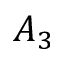<formula> <loc_0><loc_0><loc_500><loc_500>A _ { 3 }</formula> 